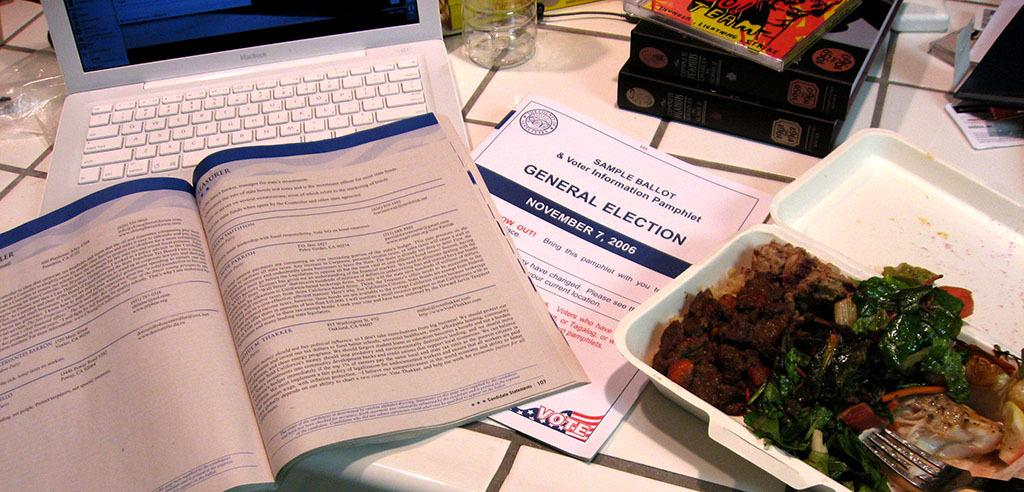What electronic device is placed on the white surface in the image? There is a laptop on the white surface. What type of items can be seen near the laptop? There are books, a plastic cover, a glass, and unspecified things on the white surface. Can you describe the container with a fork and food? There is a box with a fork and food on the white surface. Can you see any seashore or volleyball in the image? No, there is no seashore or volleyball present in the image. Is there a quill pen visible in the image? No, there is no quill pen present in the image. 